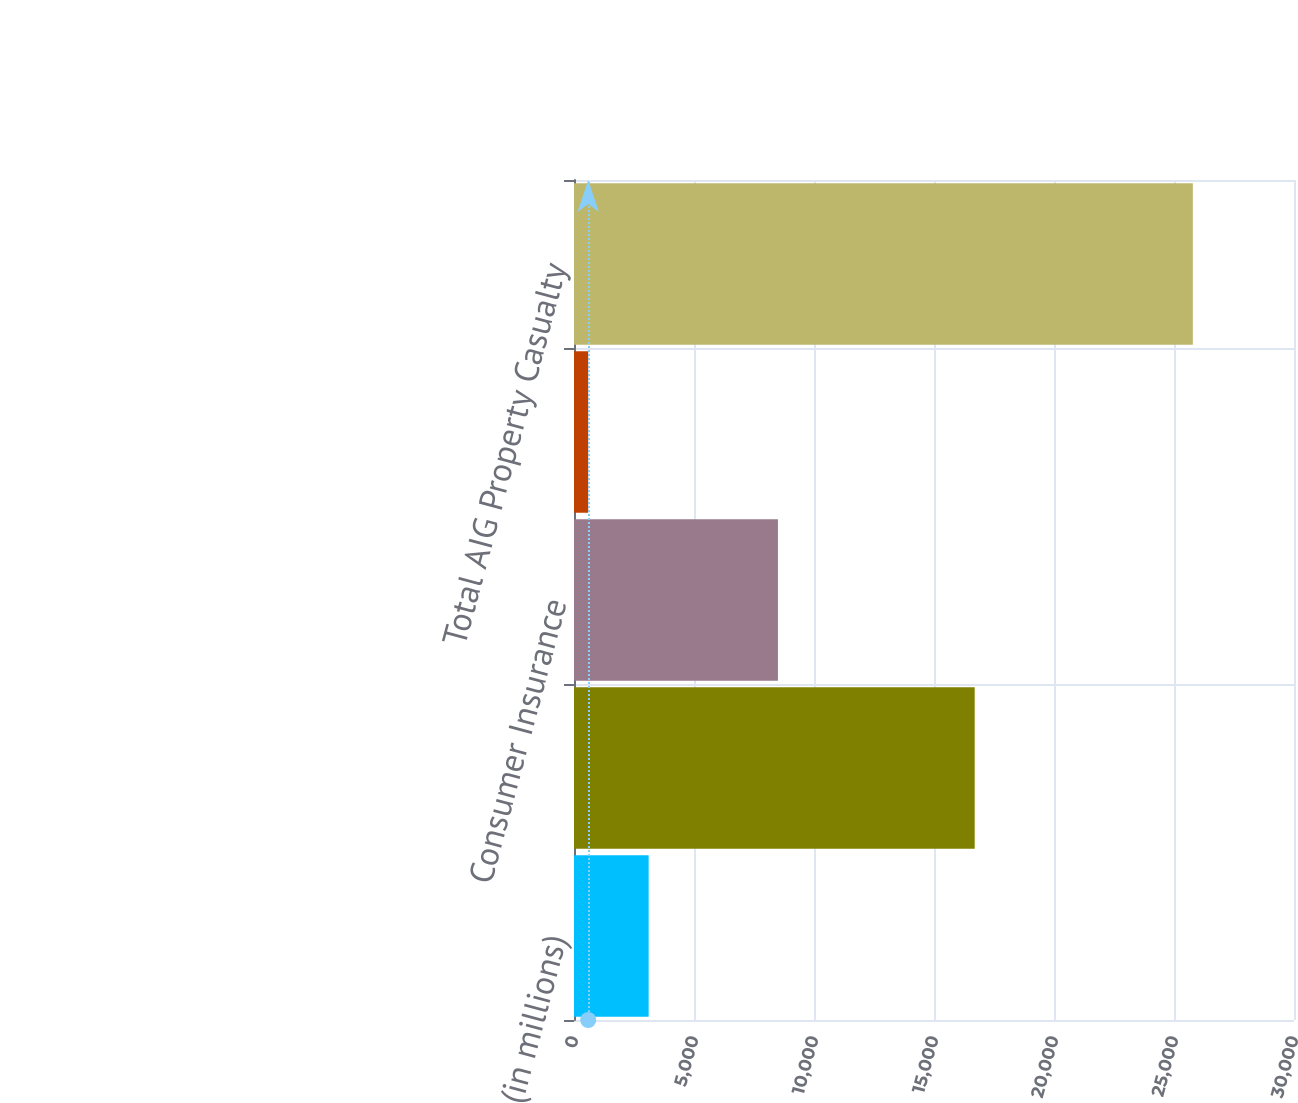Convert chart. <chart><loc_0><loc_0><loc_500><loc_500><bar_chart><fcel>(in millions)<fcel>Commercial Insurance<fcel>Consumer Insurance<fcel>Other<fcel>Total AIG Property Casualty<nl><fcel>3110.4<fcel>16696<fcel>8498<fcel>591<fcel>25785<nl></chart> 